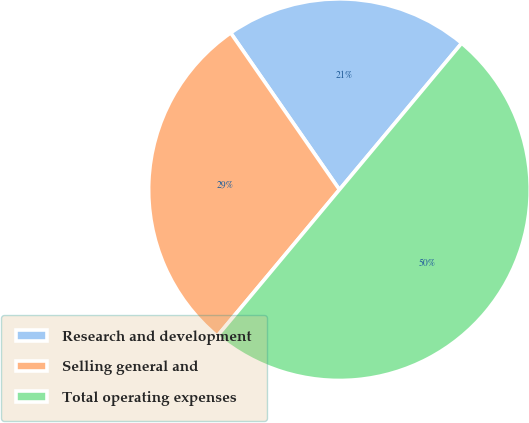Convert chart. <chart><loc_0><loc_0><loc_500><loc_500><pie_chart><fcel>Research and development<fcel>Selling general and<fcel>Total operating expenses<nl><fcel>20.72%<fcel>29.28%<fcel>50.0%<nl></chart> 